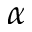Convert formula to latex. <formula><loc_0><loc_0><loc_500><loc_500>\alpha</formula> 